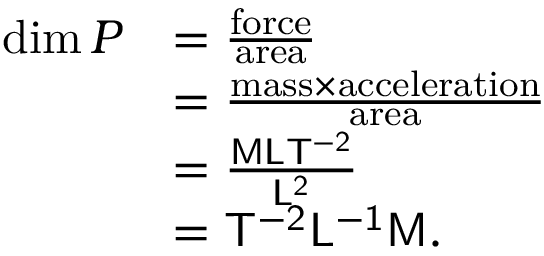Convert formula to latex. <formula><loc_0><loc_0><loc_500><loc_500>{ \begin{array} { r l } { \dim P } & { = { \frac { f o r c e } { a r e a } } } \\ & { = { \frac { { m a s s } \times { a c c e l e r a t i o n } } { a r e a } } } \\ & { = { \frac { M L T ^ { - 2 } } { L ^ { 2 } } } } \\ & { = { T ^ { - 2 } L ^ { - 1 } M } . } \end{array} }</formula> 